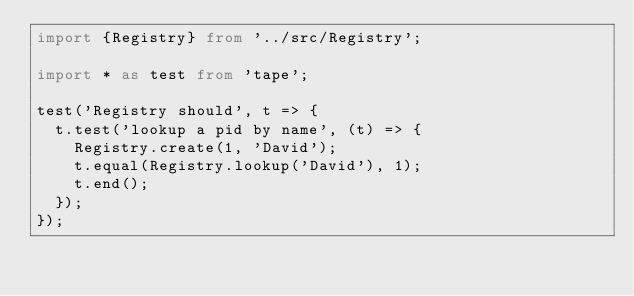<code> <loc_0><loc_0><loc_500><loc_500><_TypeScript_>import {Registry} from '../src/Registry';

import * as test from 'tape';

test('Registry should', t => {
  t.test('lookup a pid by name', (t) => {
    Registry.create(1, 'David');
    t.equal(Registry.lookup('David'), 1);
    t.end();
  });
});
</code> 